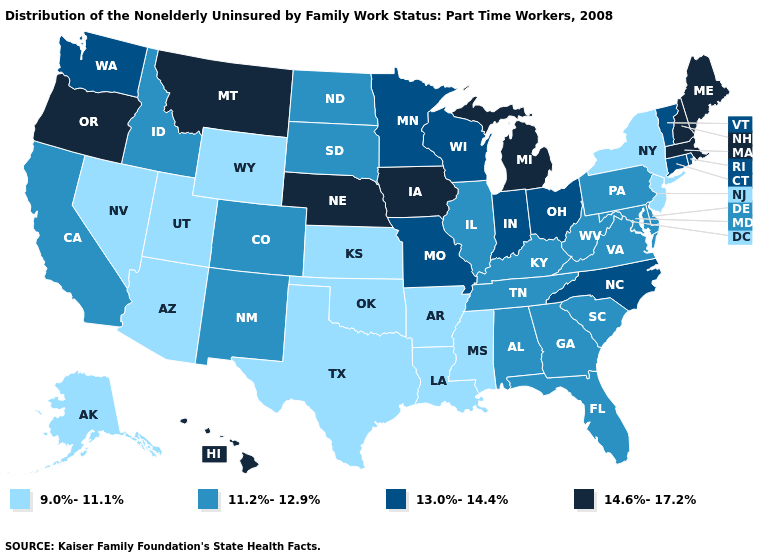Does Alaska have the lowest value in the USA?
Concise answer only. Yes. Name the states that have a value in the range 14.6%-17.2%?
Be succinct. Hawaii, Iowa, Maine, Massachusetts, Michigan, Montana, Nebraska, New Hampshire, Oregon. Name the states that have a value in the range 14.6%-17.2%?
Short answer required. Hawaii, Iowa, Maine, Massachusetts, Michigan, Montana, Nebraska, New Hampshire, Oregon. What is the lowest value in states that border Kentucky?
Be succinct. 11.2%-12.9%. Does the map have missing data?
Quick response, please. No. Does West Virginia have a lower value than Colorado?
Give a very brief answer. No. Among the states that border Illinois , which have the highest value?
Quick response, please. Iowa. How many symbols are there in the legend?
Write a very short answer. 4. Among the states that border Ohio , does Michigan have the highest value?
Short answer required. Yes. Is the legend a continuous bar?
Short answer required. No. Name the states that have a value in the range 13.0%-14.4%?
Write a very short answer. Connecticut, Indiana, Minnesota, Missouri, North Carolina, Ohio, Rhode Island, Vermont, Washington, Wisconsin. Does Indiana have the lowest value in the USA?
Give a very brief answer. No. What is the highest value in states that border Alabama?
Be succinct. 11.2%-12.9%. What is the highest value in states that border Mississippi?
Short answer required. 11.2%-12.9%. 